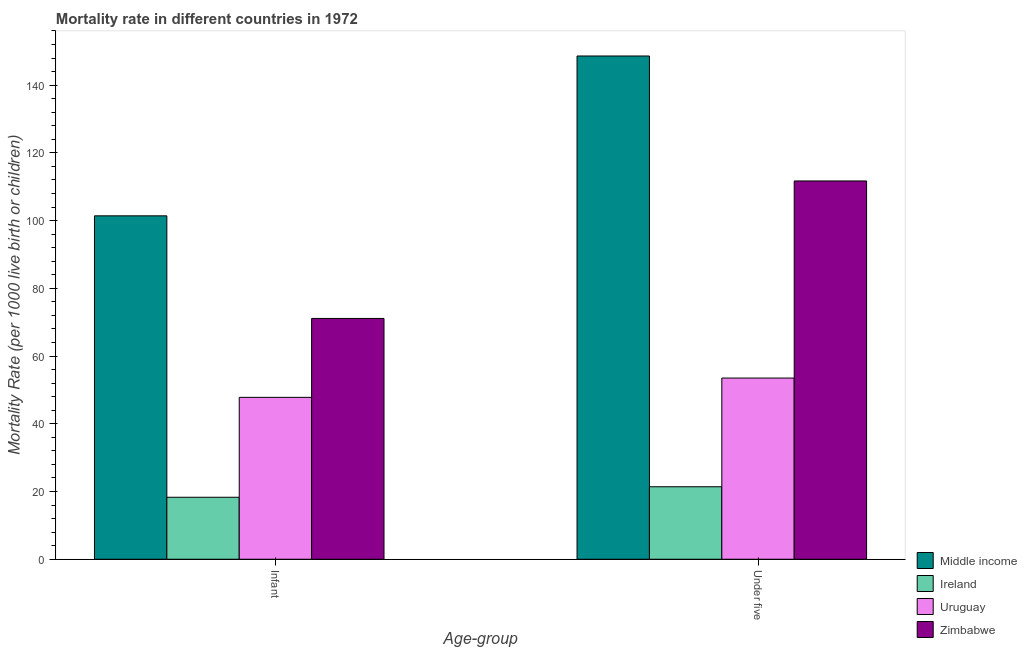Are the number of bars per tick equal to the number of legend labels?
Provide a succinct answer. Yes. What is the label of the 2nd group of bars from the left?
Ensure brevity in your answer.  Under five. What is the under-5 mortality rate in Middle income?
Provide a succinct answer. 148.6. Across all countries, what is the maximum under-5 mortality rate?
Give a very brief answer. 148.6. Across all countries, what is the minimum infant mortality rate?
Your answer should be very brief. 18.3. In which country was the infant mortality rate maximum?
Offer a very short reply. Middle income. In which country was the infant mortality rate minimum?
Offer a terse response. Ireland. What is the total infant mortality rate in the graph?
Provide a succinct answer. 238.6. What is the difference between the under-5 mortality rate in Uruguay and that in Zimbabwe?
Provide a short and direct response. -58.2. What is the difference between the under-5 mortality rate in Zimbabwe and the infant mortality rate in Uruguay?
Keep it short and to the point. 63.9. What is the average under-5 mortality rate per country?
Offer a terse response. 83.8. What is the difference between the infant mortality rate and under-5 mortality rate in Middle income?
Make the answer very short. -47.2. In how many countries, is the under-5 mortality rate greater than 52 ?
Ensure brevity in your answer.  3. What is the ratio of the infant mortality rate in Uruguay to that in Zimbabwe?
Keep it short and to the point. 0.67. What does the 3rd bar from the left in Under five represents?
Offer a terse response. Uruguay. What does the 3rd bar from the right in Under five represents?
Keep it short and to the point. Ireland. What is the difference between two consecutive major ticks on the Y-axis?
Your response must be concise. 20. Are the values on the major ticks of Y-axis written in scientific E-notation?
Ensure brevity in your answer.  No. How are the legend labels stacked?
Provide a short and direct response. Vertical. What is the title of the graph?
Make the answer very short. Mortality rate in different countries in 1972. Does "Cote d'Ivoire" appear as one of the legend labels in the graph?
Provide a short and direct response. No. What is the label or title of the X-axis?
Keep it short and to the point. Age-group. What is the label or title of the Y-axis?
Ensure brevity in your answer.  Mortality Rate (per 1000 live birth or children). What is the Mortality Rate (per 1000 live birth or children) of Middle income in Infant?
Provide a short and direct response. 101.4. What is the Mortality Rate (per 1000 live birth or children) of Ireland in Infant?
Provide a short and direct response. 18.3. What is the Mortality Rate (per 1000 live birth or children) of Uruguay in Infant?
Provide a short and direct response. 47.8. What is the Mortality Rate (per 1000 live birth or children) in Zimbabwe in Infant?
Your response must be concise. 71.1. What is the Mortality Rate (per 1000 live birth or children) in Middle income in Under five?
Keep it short and to the point. 148.6. What is the Mortality Rate (per 1000 live birth or children) in Ireland in Under five?
Ensure brevity in your answer.  21.4. What is the Mortality Rate (per 1000 live birth or children) in Uruguay in Under five?
Give a very brief answer. 53.5. What is the Mortality Rate (per 1000 live birth or children) in Zimbabwe in Under five?
Make the answer very short. 111.7. Across all Age-group, what is the maximum Mortality Rate (per 1000 live birth or children) of Middle income?
Offer a very short reply. 148.6. Across all Age-group, what is the maximum Mortality Rate (per 1000 live birth or children) in Ireland?
Offer a very short reply. 21.4. Across all Age-group, what is the maximum Mortality Rate (per 1000 live birth or children) of Uruguay?
Provide a succinct answer. 53.5. Across all Age-group, what is the maximum Mortality Rate (per 1000 live birth or children) of Zimbabwe?
Your response must be concise. 111.7. Across all Age-group, what is the minimum Mortality Rate (per 1000 live birth or children) of Middle income?
Your answer should be very brief. 101.4. Across all Age-group, what is the minimum Mortality Rate (per 1000 live birth or children) in Uruguay?
Your answer should be compact. 47.8. Across all Age-group, what is the minimum Mortality Rate (per 1000 live birth or children) in Zimbabwe?
Give a very brief answer. 71.1. What is the total Mortality Rate (per 1000 live birth or children) of Middle income in the graph?
Your answer should be compact. 250. What is the total Mortality Rate (per 1000 live birth or children) of Ireland in the graph?
Provide a short and direct response. 39.7. What is the total Mortality Rate (per 1000 live birth or children) of Uruguay in the graph?
Offer a terse response. 101.3. What is the total Mortality Rate (per 1000 live birth or children) in Zimbabwe in the graph?
Keep it short and to the point. 182.8. What is the difference between the Mortality Rate (per 1000 live birth or children) in Middle income in Infant and that in Under five?
Your answer should be very brief. -47.2. What is the difference between the Mortality Rate (per 1000 live birth or children) of Ireland in Infant and that in Under five?
Provide a short and direct response. -3.1. What is the difference between the Mortality Rate (per 1000 live birth or children) of Zimbabwe in Infant and that in Under five?
Your answer should be very brief. -40.6. What is the difference between the Mortality Rate (per 1000 live birth or children) in Middle income in Infant and the Mortality Rate (per 1000 live birth or children) in Ireland in Under five?
Your answer should be compact. 80. What is the difference between the Mortality Rate (per 1000 live birth or children) in Middle income in Infant and the Mortality Rate (per 1000 live birth or children) in Uruguay in Under five?
Your answer should be compact. 47.9. What is the difference between the Mortality Rate (per 1000 live birth or children) in Ireland in Infant and the Mortality Rate (per 1000 live birth or children) in Uruguay in Under five?
Make the answer very short. -35.2. What is the difference between the Mortality Rate (per 1000 live birth or children) in Ireland in Infant and the Mortality Rate (per 1000 live birth or children) in Zimbabwe in Under five?
Offer a terse response. -93.4. What is the difference between the Mortality Rate (per 1000 live birth or children) of Uruguay in Infant and the Mortality Rate (per 1000 live birth or children) of Zimbabwe in Under five?
Keep it short and to the point. -63.9. What is the average Mortality Rate (per 1000 live birth or children) of Middle income per Age-group?
Your answer should be very brief. 125. What is the average Mortality Rate (per 1000 live birth or children) of Ireland per Age-group?
Your response must be concise. 19.85. What is the average Mortality Rate (per 1000 live birth or children) of Uruguay per Age-group?
Provide a short and direct response. 50.65. What is the average Mortality Rate (per 1000 live birth or children) in Zimbabwe per Age-group?
Make the answer very short. 91.4. What is the difference between the Mortality Rate (per 1000 live birth or children) in Middle income and Mortality Rate (per 1000 live birth or children) in Ireland in Infant?
Your answer should be compact. 83.1. What is the difference between the Mortality Rate (per 1000 live birth or children) of Middle income and Mortality Rate (per 1000 live birth or children) of Uruguay in Infant?
Your response must be concise. 53.6. What is the difference between the Mortality Rate (per 1000 live birth or children) of Middle income and Mortality Rate (per 1000 live birth or children) of Zimbabwe in Infant?
Offer a terse response. 30.3. What is the difference between the Mortality Rate (per 1000 live birth or children) in Ireland and Mortality Rate (per 1000 live birth or children) in Uruguay in Infant?
Give a very brief answer. -29.5. What is the difference between the Mortality Rate (per 1000 live birth or children) in Ireland and Mortality Rate (per 1000 live birth or children) in Zimbabwe in Infant?
Ensure brevity in your answer.  -52.8. What is the difference between the Mortality Rate (per 1000 live birth or children) of Uruguay and Mortality Rate (per 1000 live birth or children) of Zimbabwe in Infant?
Your response must be concise. -23.3. What is the difference between the Mortality Rate (per 1000 live birth or children) of Middle income and Mortality Rate (per 1000 live birth or children) of Ireland in Under five?
Provide a succinct answer. 127.2. What is the difference between the Mortality Rate (per 1000 live birth or children) of Middle income and Mortality Rate (per 1000 live birth or children) of Uruguay in Under five?
Your answer should be very brief. 95.1. What is the difference between the Mortality Rate (per 1000 live birth or children) in Middle income and Mortality Rate (per 1000 live birth or children) in Zimbabwe in Under five?
Provide a short and direct response. 36.9. What is the difference between the Mortality Rate (per 1000 live birth or children) in Ireland and Mortality Rate (per 1000 live birth or children) in Uruguay in Under five?
Your answer should be compact. -32.1. What is the difference between the Mortality Rate (per 1000 live birth or children) in Ireland and Mortality Rate (per 1000 live birth or children) in Zimbabwe in Under five?
Provide a succinct answer. -90.3. What is the difference between the Mortality Rate (per 1000 live birth or children) in Uruguay and Mortality Rate (per 1000 live birth or children) in Zimbabwe in Under five?
Give a very brief answer. -58.2. What is the ratio of the Mortality Rate (per 1000 live birth or children) in Middle income in Infant to that in Under five?
Make the answer very short. 0.68. What is the ratio of the Mortality Rate (per 1000 live birth or children) in Ireland in Infant to that in Under five?
Ensure brevity in your answer.  0.86. What is the ratio of the Mortality Rate (per 1000 live birth or children) in Uruguay in Infant to that in Under five?
Your answer should be compact. 0.89. What is the ratio of the Mortality Rate (per 1000 live birth or children) of Zimbabwe in Infant to that in Under five?
Your answer should be very brief. 0.64. What is the difference between the highest and the second highest Mortality Rate (per 1000 live birth or children) in Middle income?
Provide a succinct answer. 47.2. What is the difference between the highest and the second highest Mortality Rate (per 1000 live birth or children) in Uruguay?
Offer a very short reply. 5.7. What is the difference between the highest and the second highest Mortality Rate (per 1000 live birth or children) of Zimbabwe?
Offer a very short reply. 40.6. What is the difference between the highest and the lowest Mortality Rate (per 1000 live birth or children) in Middle income?
Offer a very short reply. 47.2. What is the difference between the highest and the lowest Mortality Rate (per 1000 live birth or children) in Zimbabwe?
Give a very brief answer. 40.6. 